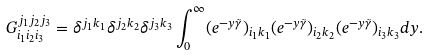Convert formula to latex. <formula><loc_0><loc_0><loc_500><loc_500>G _ { i _ { 1 } i _ { 2 } i _ { 3 } } ^ { j _ { 1 } j _ { 2 } j _ { 3 } } = \delta ^ { j _ { 1 } k _ { 1 } } \delta ^ { j _ { 2 } k _ { 2 } } \delta ^ { j _ { 3 } k _ { 3 } } \int _ { 0 } ^ { \infty } ( e ^ { - y \tilde { \gamma } } ) _ { i _ { 1 } k _ { 1 } } ( e ^ { - y \tilde { \gamma } } ) _ { i _ { 2 } k _ { 2 } } ( e ^ { - y \tilde { \gamma } } ) _ { i _ { 3 } k _ { 3 } } d y .</formula> 